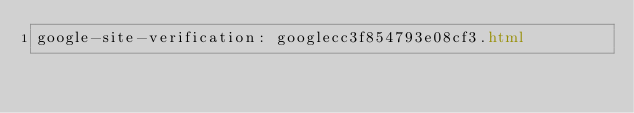<code> <loc_0><loc_0><loc_500><loc_500><_HTML_>google-site-verification: googlecc3f854793e08cf3.html</code> 